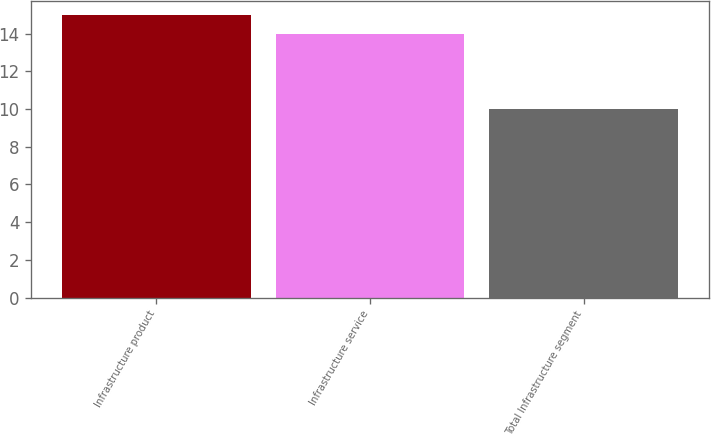<chart> <loc_0><loc_0><loc_500><loc_500><bar_chart><fcel>Infrastructure product<fcel>Infrastructure service<fcel>Total Infrastructure segment<nl><fcel>15<fcel>14<fcel>10<nl></chart> 